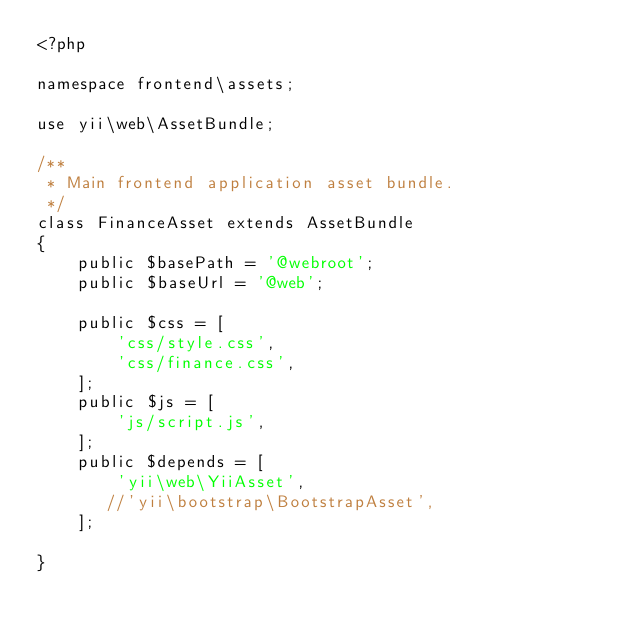<code> <loc_0><loc_0><loc_500><loc_500><_PHP_><?php

namespace frontend\assets;

use yii\web\AssetBundle;

/**
 * Main frontend application asset bundle.
 */
class FinanceAsset extends AssetBundle
{
    public $basePath = '@webroot';
    public $baseUrl = '@web';
    
    public $css = [
        'css/style.css',
        'css/finance.css',
    ];
    public $js = [
        'js/script.js',
    ];
    public $depends = [
        'yii\web\YiiAsset',
       //'yii\bootstrap\BootstrapAsset',
    ];

}
</code> 